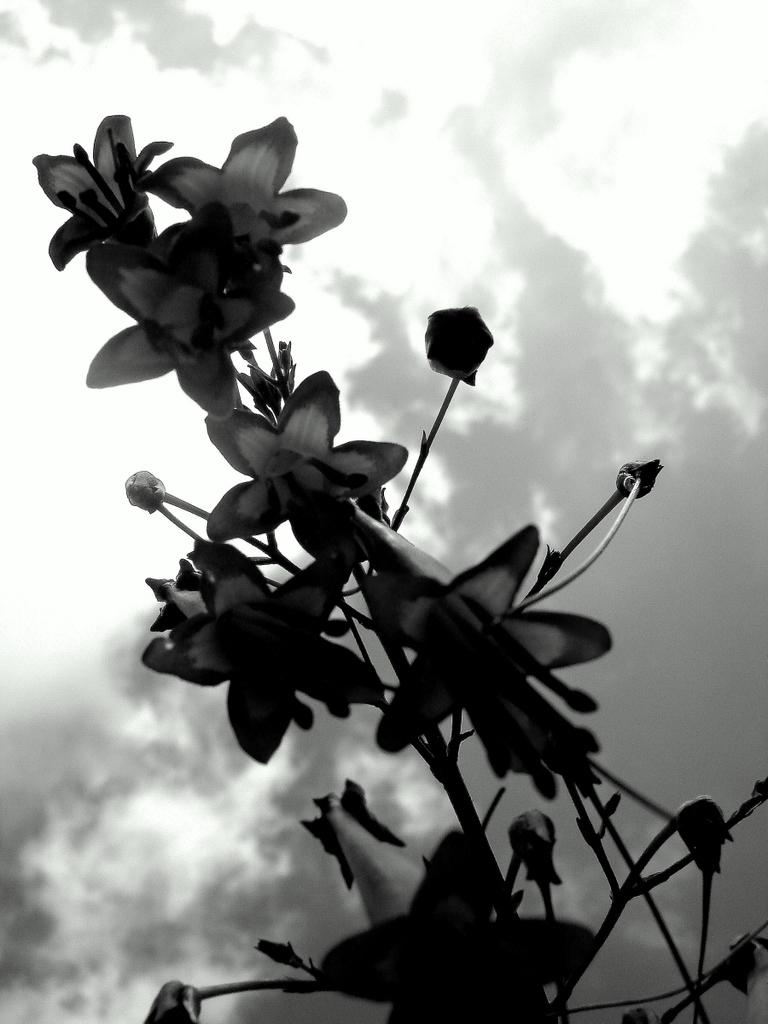What type of plant is visible in the image? There are flowers on a plant in the image. What can be seen in the background of the image? The sky is visible in the image. What is the condition of the sky in the image? Clouds are present in the sky. What type of instrument is being played by the jellyfish in the image? There is no jellyfish or instrument present in the image. 